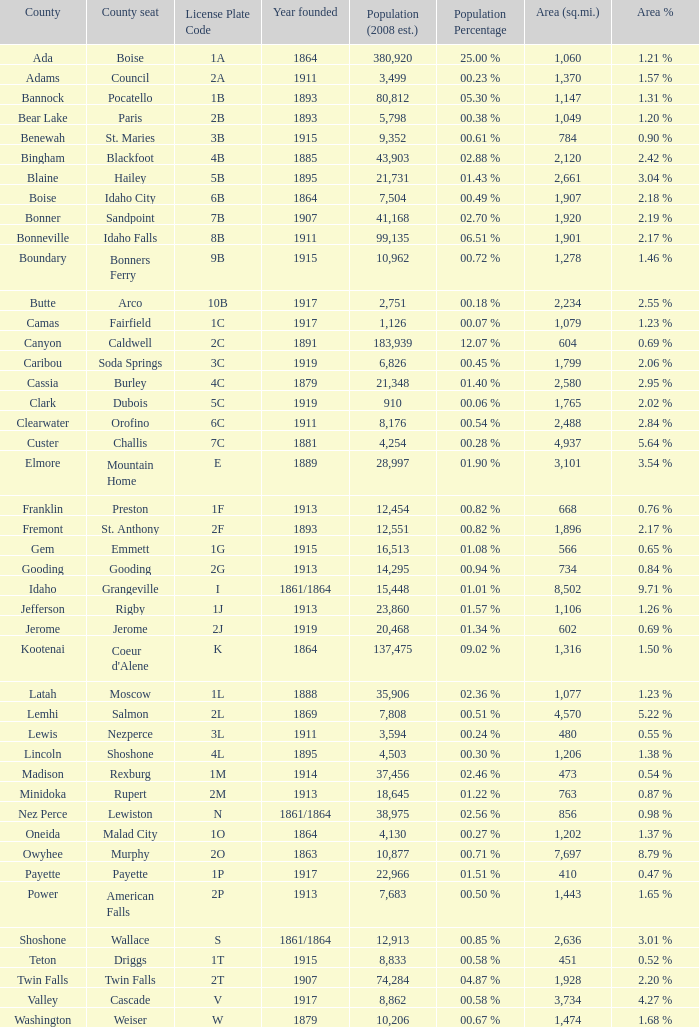What is the vehicle plate code for the territory covering an area of 784? 3B. 